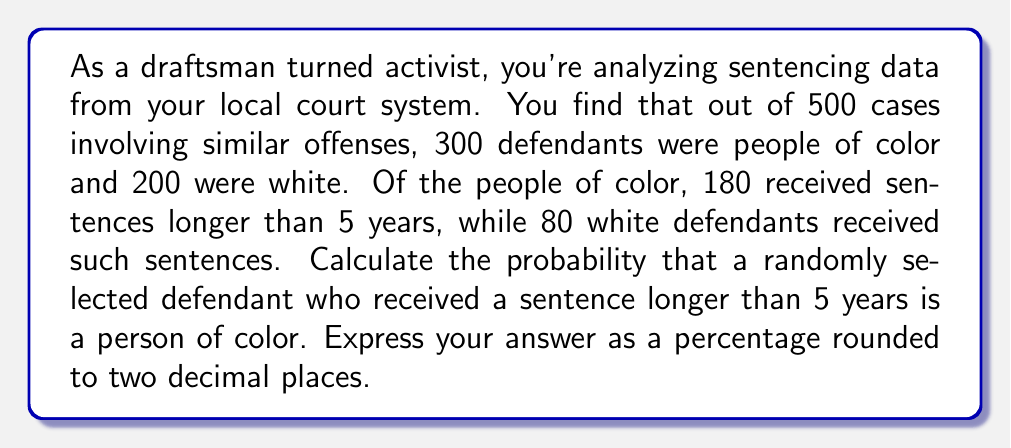Show me your answer to this math problem. To solve this problem, we'll use Bayes' Theorem. Let's define our events:

A: The defendant is a person of color
B: The defendant received a sentence longer than 5 years

We need to calculate P(A|B), which is the probability that a defendant is a person of color given that they received a sentence longer than 5 years.

Bayes' Theorem states:

$$ P(A|B) = \frac{P(B|A) \cdot P(A)}{P(B)} $$

Let's calculate each component:

1. P(A) = Probability of being a person of color = 300/500 = 0.6

2. P(B|A) = Probability of receiving a sentence > 5 years given that the defendant is a person of color = 180/300 = 0.6

3. P(B) = Overall probability of receiving a sentence > 5 years
   = (180 + 80) / 500 = 260/500 = 0.52

Now, let's plug these values into Bayes' Theorem:

$$ P(A|B) = \frac{0.6 \cdot 0.6}{0.52} = \frac{0.36}{0.52} \approx 0.6923 $$

To convert to a percentage and round to two decimal places:

0.6923 * 100 ≈ 69.23%
Answer: 69.23% 